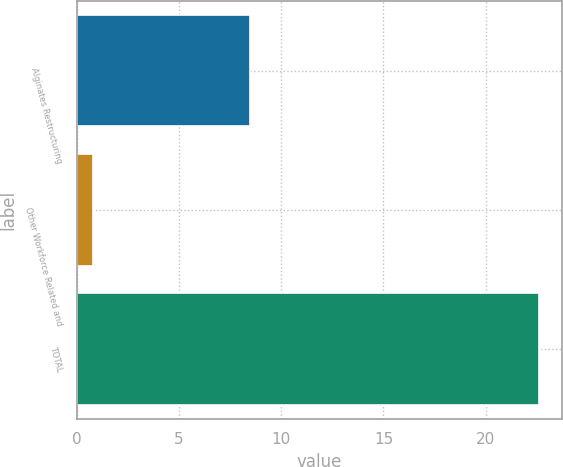Convert chart. <chart><loc_0><loc_0><loc_500><loc_500><bar_chart><fcel>Alginates Restructuring<fcel>Other Workforce Related and<fcel>TOTAL<nl><fcel>8.5<fcel>0.8<fcel>22.6<nl></chart> 